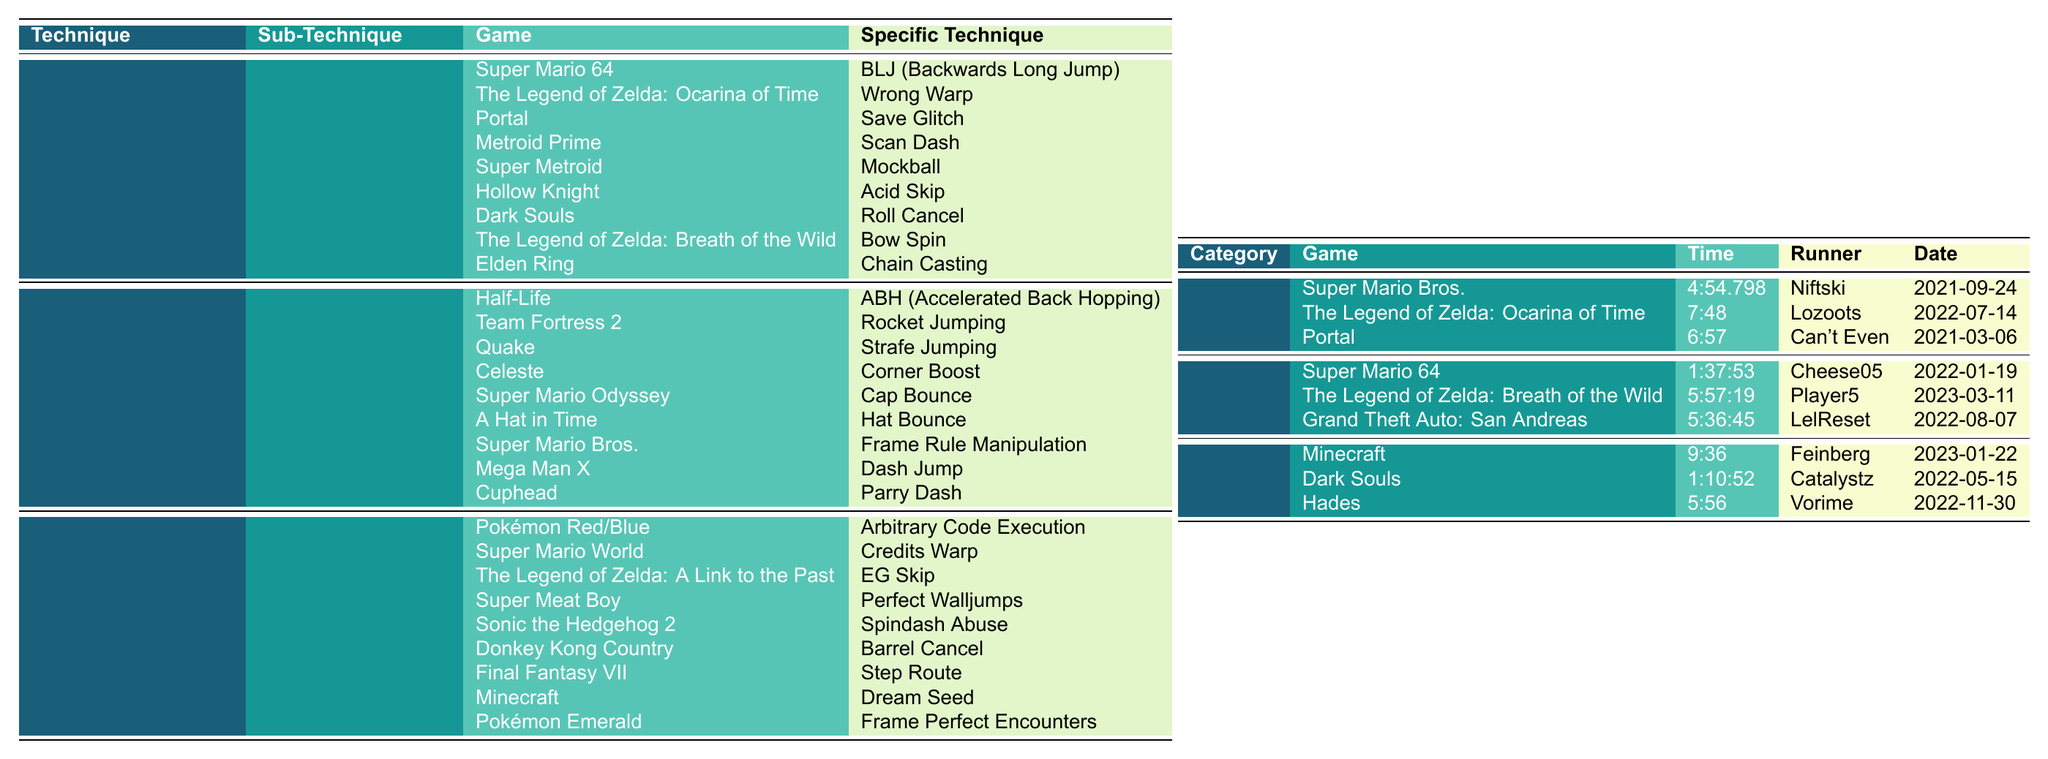What is the specific technique used in Super Mario 64 for Out-of-Bounds? According to the table, the specific technique for Out-of-Bounds in Super Mario 64 is "BLJ (Backwards Long Jump)."
Answer: BLJ (Backwards Long Jump) Who set the world record for any% in The Legend of Zelda: Ocarina of Time? In the table, the entry for the any% category of The Legend of Zelda: Ocarina of Time shows that the runner is "Lozoots."
Answer: Lozoots What is the time recorded for the 100% category in Grand Theft Auto: San Andreas? The table lists the completion time for the 100% category in Grand Theft Auto: San Andreas as "5:36:45."
Answer: 5:36:45 Is there a world record for the glitchless category in Dark Souls according to the table? The table has an entry for Dark Souls under the glitchless category, indicating that there is indeed a world record listed.
Answer: Yes Which game features the technique "Chain Casting"? Referring to the table, "Chain Casting" is the specific technique listed under the Animation Cancelling sub-technique for Elden Ring.
Answer: Elden Ring What is the average completion time for the any% category among the three games listed? First, we convert each time into seconds: Super Mario Bros. is 294.798 seconds, The Legend of Zelda: Ocarina of Time is 468 seconds, and Portal is 417 seconds. Their sum is 294.798 + 468 + 417 = 1179.798 seconds. Then, we divide this by the number of games (3), which gives us an average of 1179.798 / 3 = 393.266 seconds or approximately 393 seconds when rounded.
Answer: Approximately 393 seconds Which game has the longest recorded time in the 100% category? Checking the times in the 100% category, Grand Theft Auto: San Andreas has the longest time at 5:36:45 compared to the other two games listed.
Answer: Grand Theft Auto: San Andreas How many techniques are listed under the 'Tool-Assisted' category? The table shows three sub-techniques listed under the Tool-Assisted category: Memory Manipulation, Input Optimization, and RNG Manipulation. Therefore, there are 3 techniques in total.
Answer: 3 What was the runner's name for the world record in the glitchless category for Hades? The entry for Hades in the glitchless category lists "Vorime" as the runner's name.
Answer: Vorime Is the time for Super Mario 64 in the 100% category faster or slower than that of The Legend of Zelda: Breath of the Wild in the same category? The completion time for Super Mario 64 is 1:37:53, which is 97 minutes and 53 seconds, while The Legend of Zelda: Breath of the Wild is 5:57:19, or 357 minutes and 19 seconds. Since 97 minutes is shorter than 357 minutes, Super Mario 64's time is faster.
Answer: Faster What are the names of the sub-techniques under the 'Glitches' category? In the table, the sub-techniques listed under the Glitches category are Out-of-Bounds, Sequence Breaking, and Animation Cancelling.
Answer: Out-of-Bounds, Sequence Breaking, Animation Cancelling 